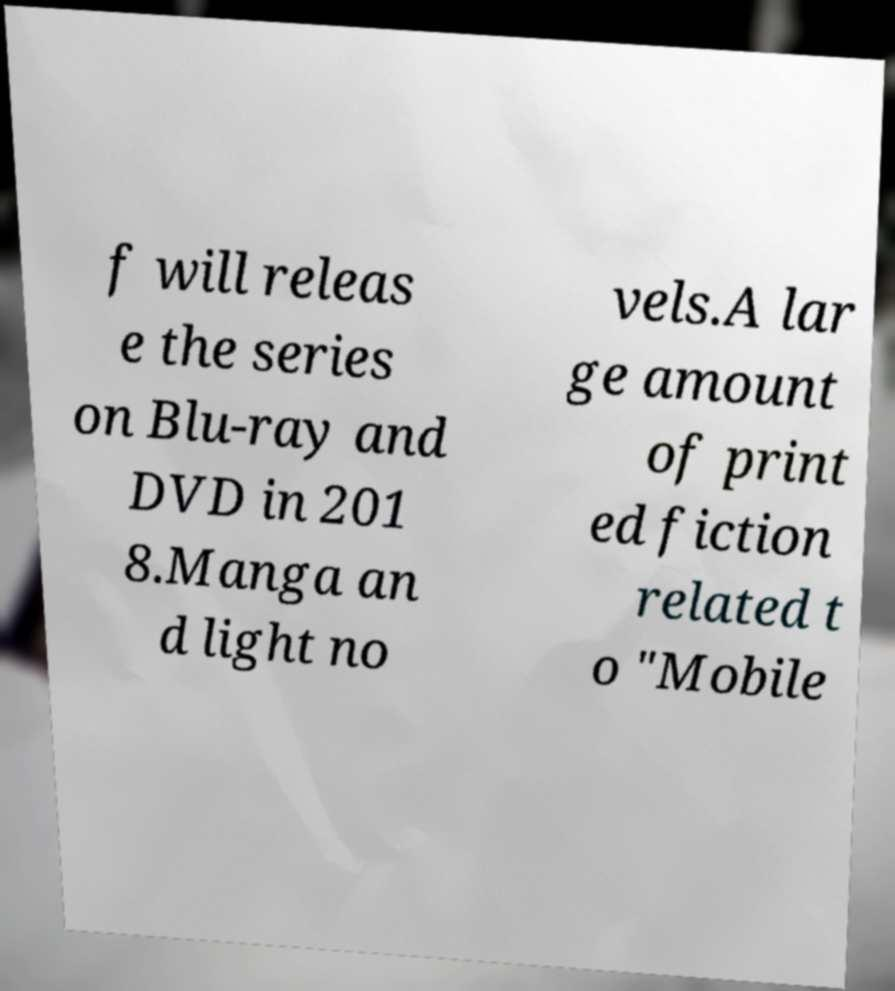Could you extract and type out the text from this image? f will releas e the series on Blu-ray and DVD in 201 8.Manga an d light no vels.A lar ge amount of print ed fiction related t o "Mobile 